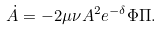Convert formula to latex. <formula><loc_0><loc_0><loc_500><loc_500>\dot { A } = - 2 \mu \nu A ^ { 2 } e ^ { - \delta } \Phi \Pi .</formula> 